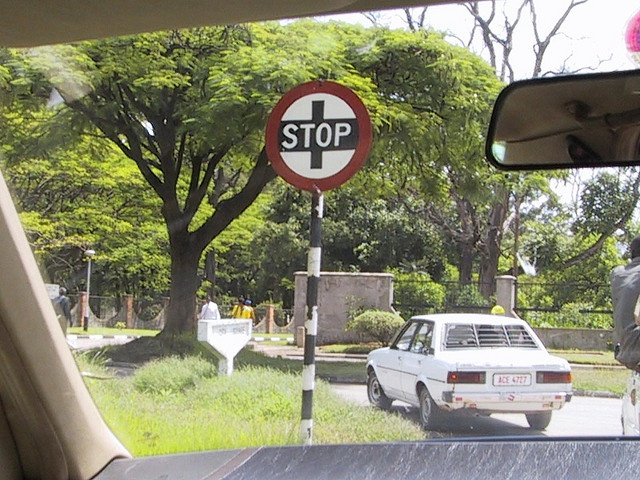Describe the objects in this image and their specific colors. I can see car in gray, lightgray, and darkgray tones, stop sign in gray, maroon, lightgray, and black tones, people in gray, darkgray, lightgray, and black tones, people in gray and darkgray tones, and people in gray, lavender, and darkgray tones in this image. 